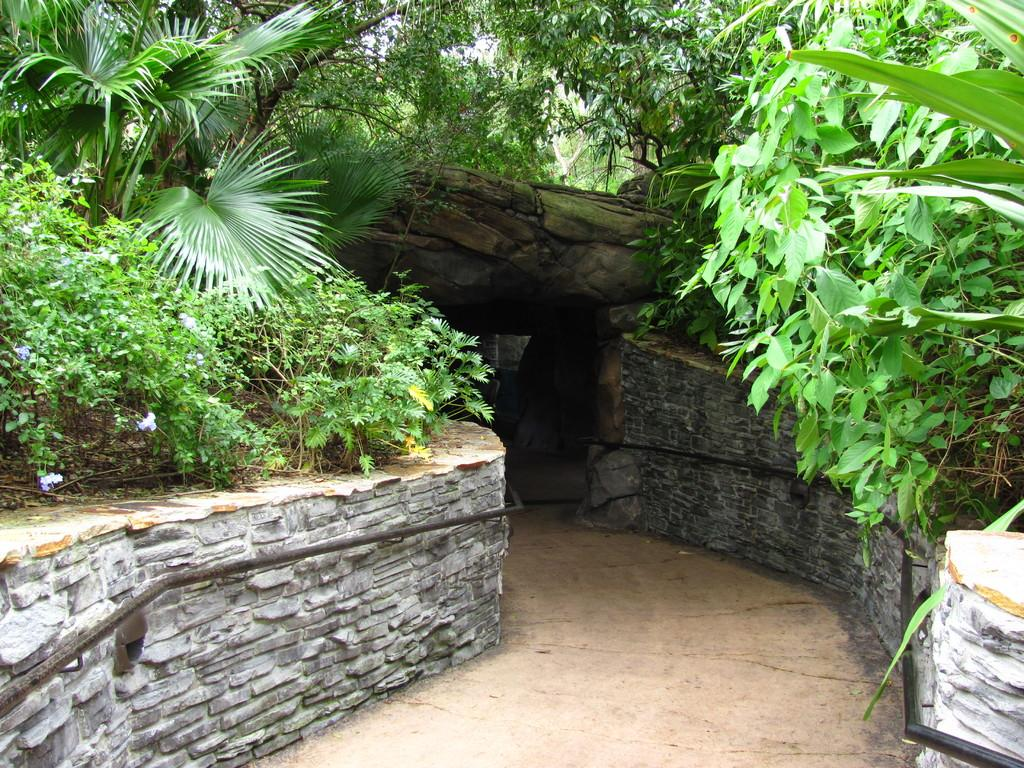What can be seen running through the image? There is a path in the image. What surrounds the path? There are walls on both sides of the path. What is on the walls? The walls have rocks on them. What can be seen in the distance in the image? There are plants and a tree in the background of the image. Can you see a person's face in the image? There is no person or face present in the image. 